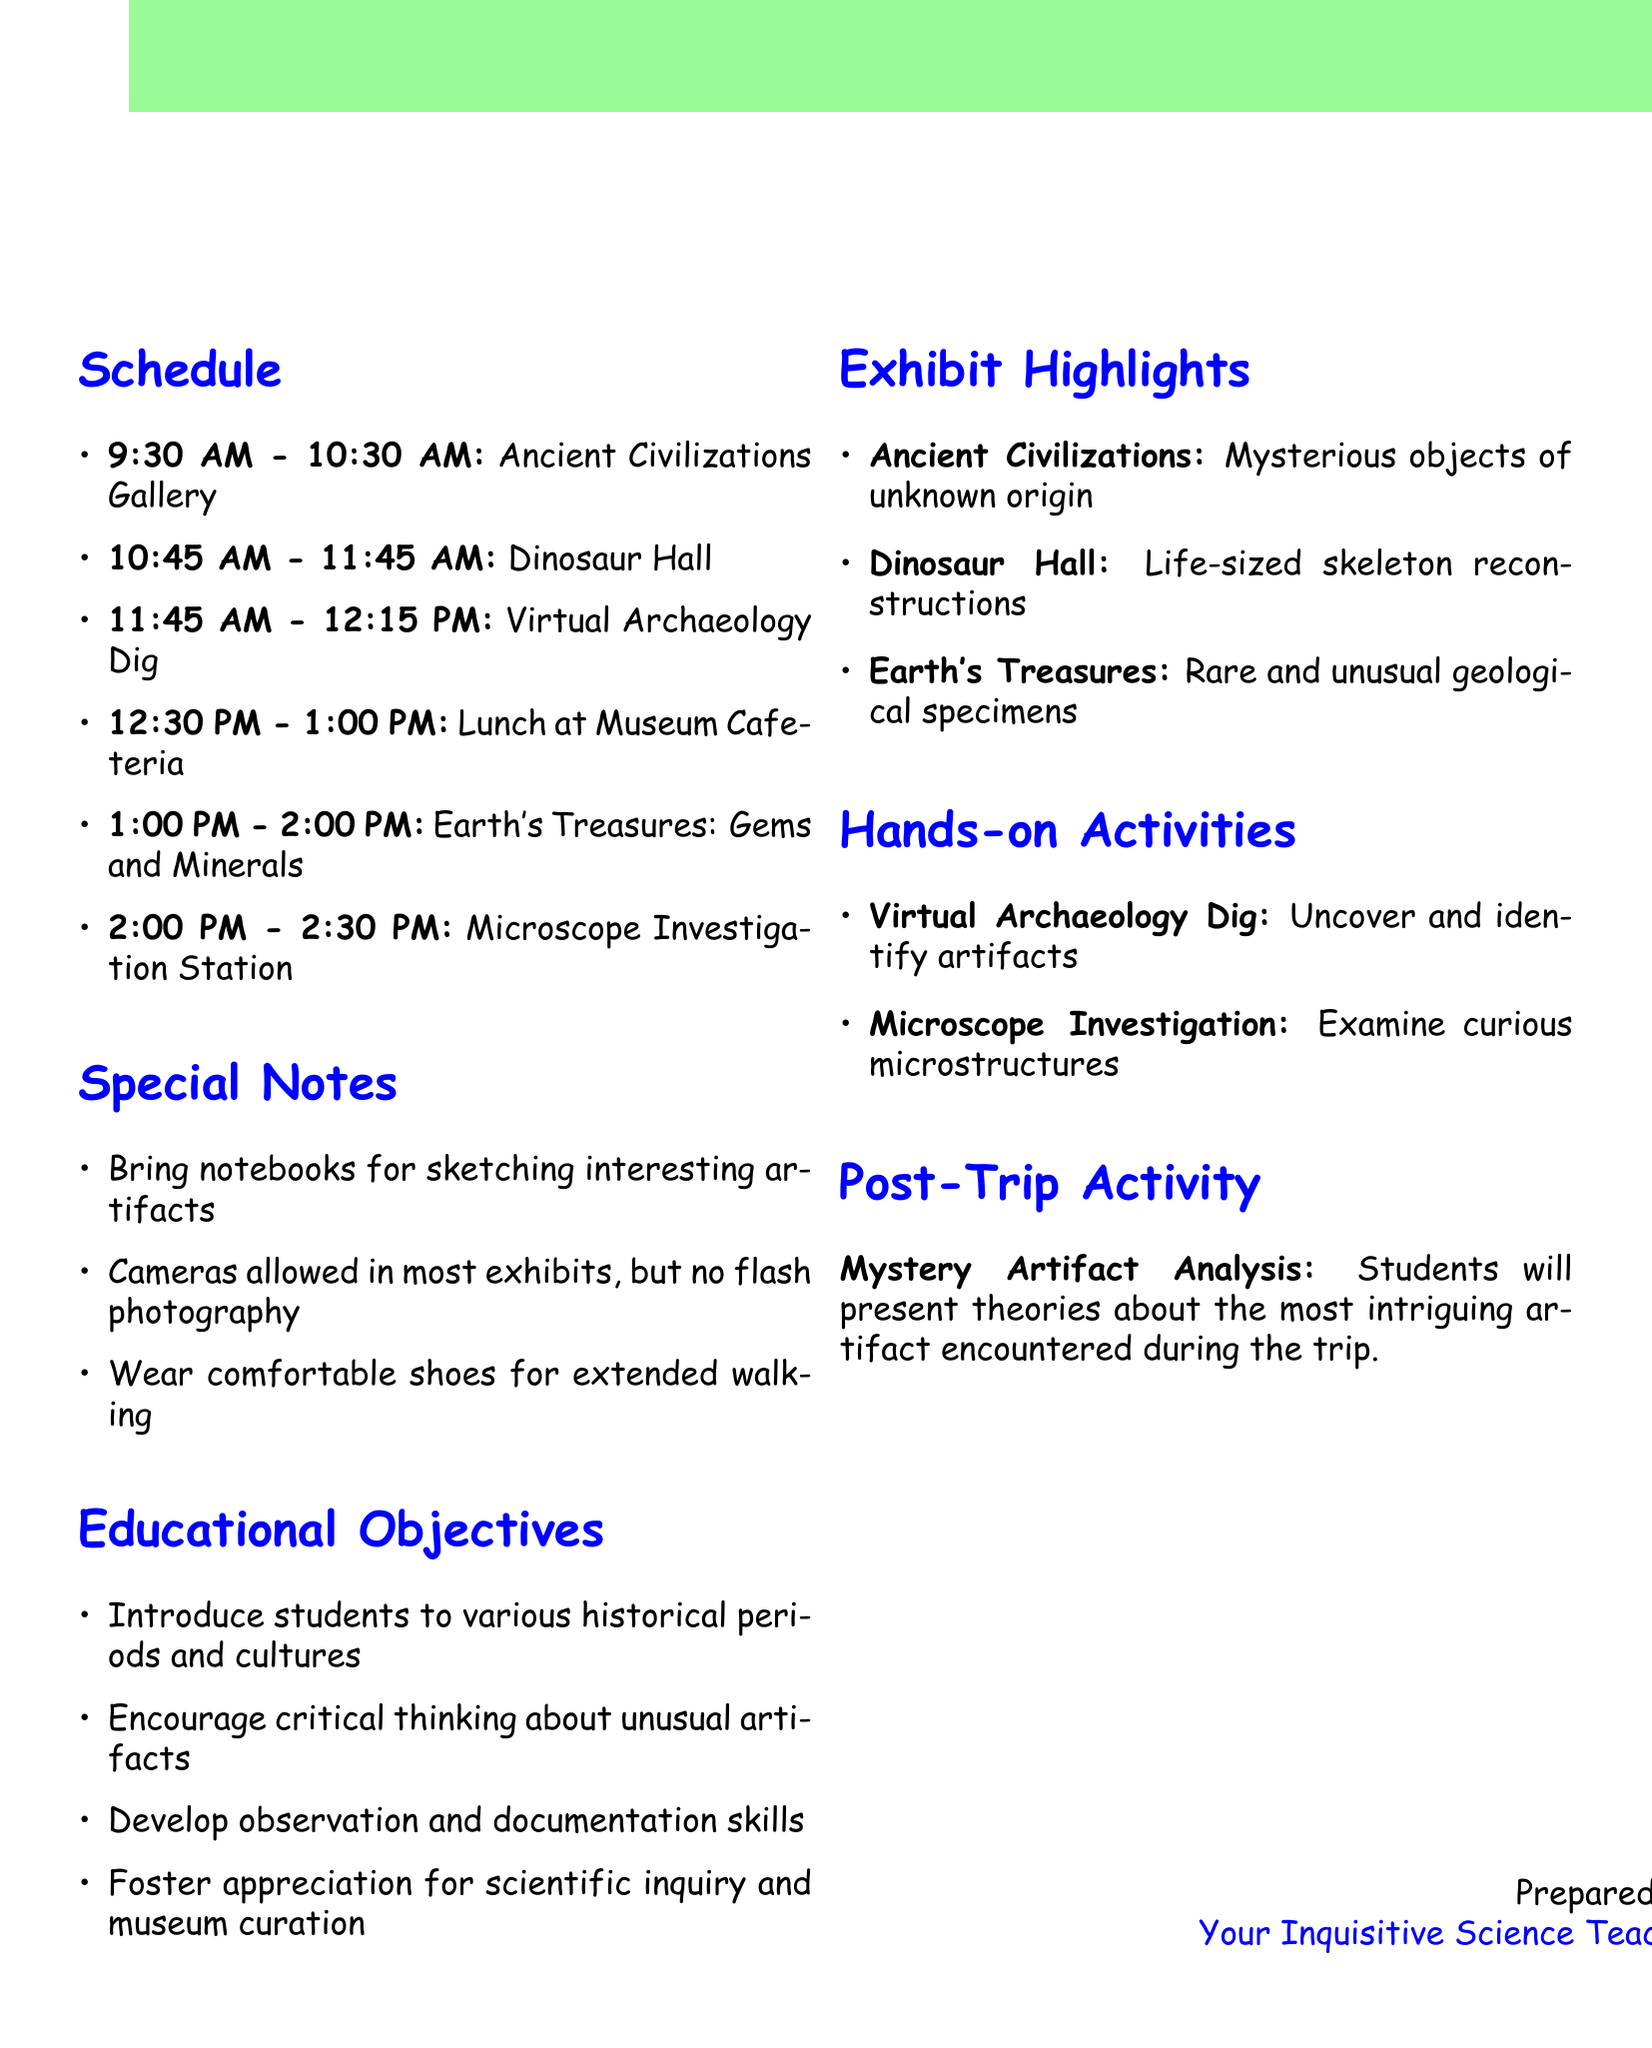What is the name of the museum? The name of the museum is provided in the document under "museum_name".
Answer: Springfield Natural History Museum What time does the field trip start? The starting time can be found in the "time_range" section of the document.
Answer: 9:00 AM How long is the lunch break? The lunch break time is included in the "lunch_break" section of the document.
Answer: 30 minutes What is one of the hands-on activities? The document lists activities under "hands_on_activities".
Answer: Virtual Archaeology Dig In which gallery can you find mysterious objects? The document describes artifacts in one of the exhibits under "exhibits".
Answer: Ancient Civilizations Gallery What are students encouraged to bring for sketching? This detail is found in the "special_notes" section of the document.
Answer: Notebooks What is the main objective of the trip? The objectives are listed under "educational_objectives".
Answer: Introduce students to various historical periods and cultures What is the time for the Microscope Investigation Station? The schedule includes specific times for each activity mentioned in the document.
Answer: 2:00 PM - 2:30 PM What is the post-trip activity called? The name of the post-trip activity is listed in the "post_trip_activity" section of the document.
Answer: Mystery Artifact Analysis 